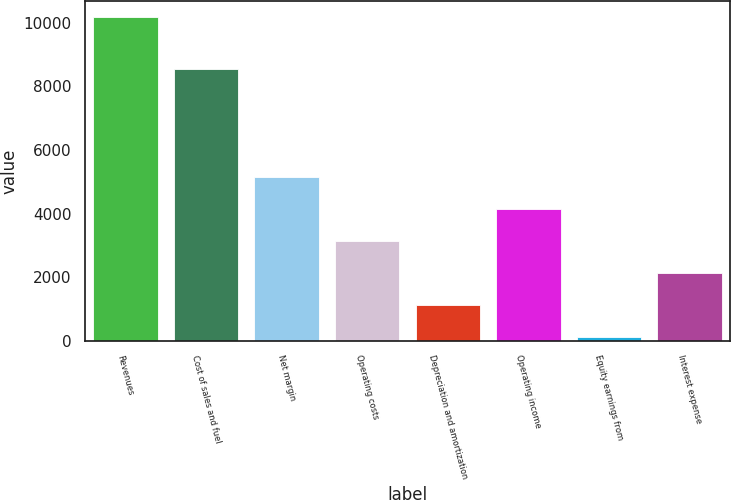<chart> <loc_0><loc_0><loc_500><loc_500><bar_chart><fcel>Revenues<fcel>Cost of sales and fuel<fcel>Net margin<fcel>Operating costs<fcel>Depreciation and amortization<fcel>Operating income<fcel>Equity earnings from<fcel>Interest expense<nl><fcel>10182.2<fcel>8540.4<fcel>5152.6<fcel>3140.76<fcel>1128.92<fcel>4146.68<fcel>123<fcel>2134.84<nl></chart> 